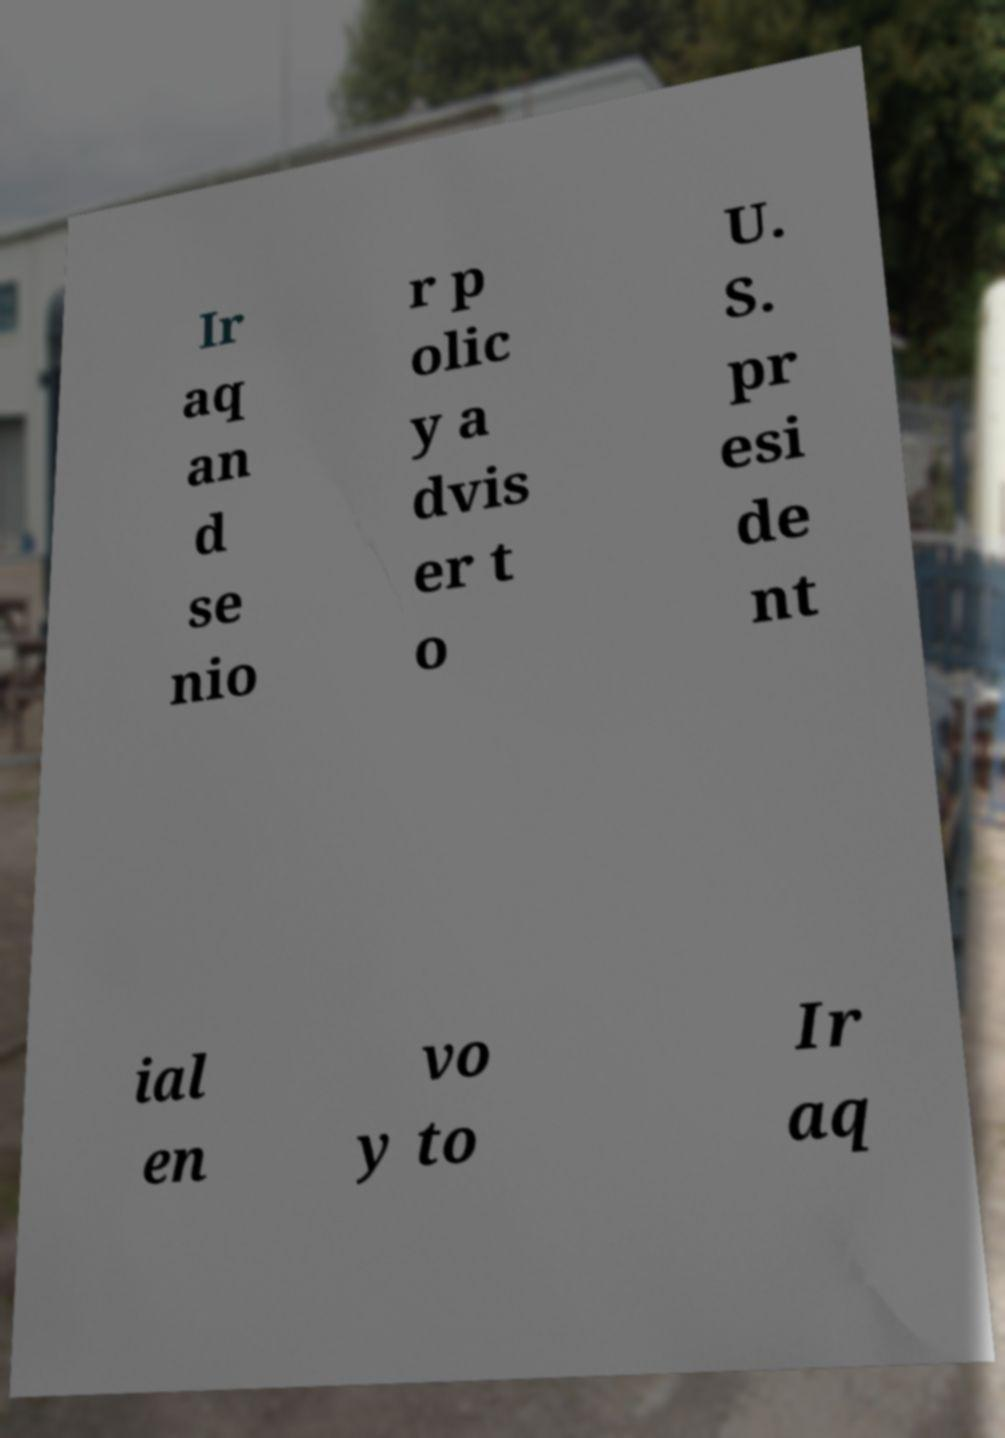Can you read and provide the text displayed in the image?This photo seems to have some interesting text. Can you extract and type it out for me? Ir aq an d se nio r p olic y a dvis er t o U. S. pr esi de nt ial en vo y to Ir aq 